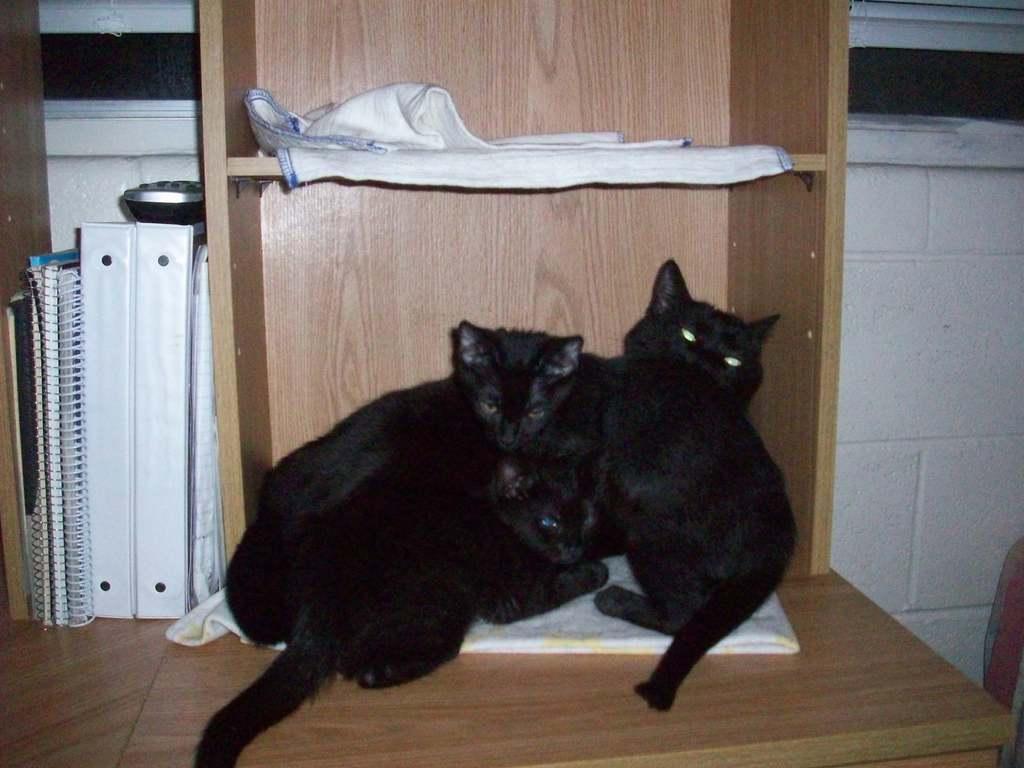Please provide a concise description of this image. We can see cats on cloth and we can see clothes, books and remote on wooden surface. Background we can see white wall. 